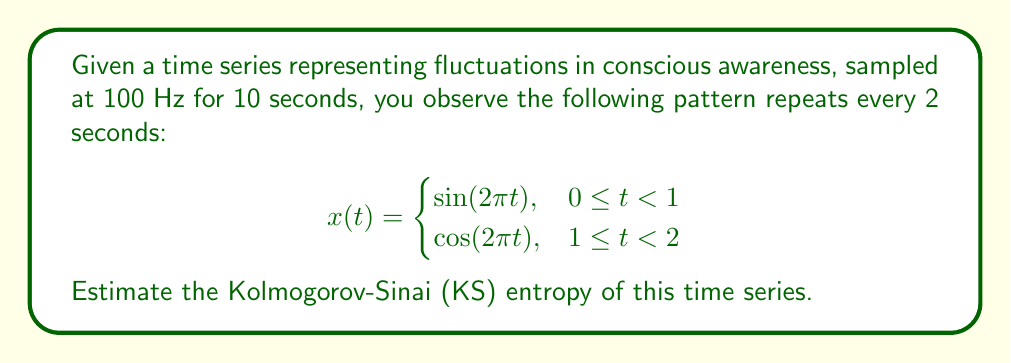Teach me how to tackle this problem. To estimate the Kolmogorov-Sinai entropy of this time series, we'll follow these steps:

1) First, we need to identify the period of the system. The pattern repeats every 2 seconds, so the period is T = 2s.

2) The KS entropy for a periodic system is 0, as there's no new information generated over time. However, due to the finite sampling rate, we need to consider the information content per sample.

3) The sampling rate is 100 Hz, so there are 200 samples per period (100 samples/s * 2s).

4) The information content per period is approximately the logarithm of the number of distinct states. In this case, we have 200 distinct states per period.

5) The KS entropy can be estimated as:

   $$h_{KS} \approx \frac{\ln(200)}{T} = \frac{\ln(200)}{2} \text{ bits/s}$$

6) Calculate:
   $$h_{KS} \approx \frac{\ln(200)}{2} \approx 2.65 \text{ bits/s}$$

This value represents the average rate of information generation in the time series, accounting for the finite sampling rate.
Answer: $2.65 \text{ bits/s}$ 